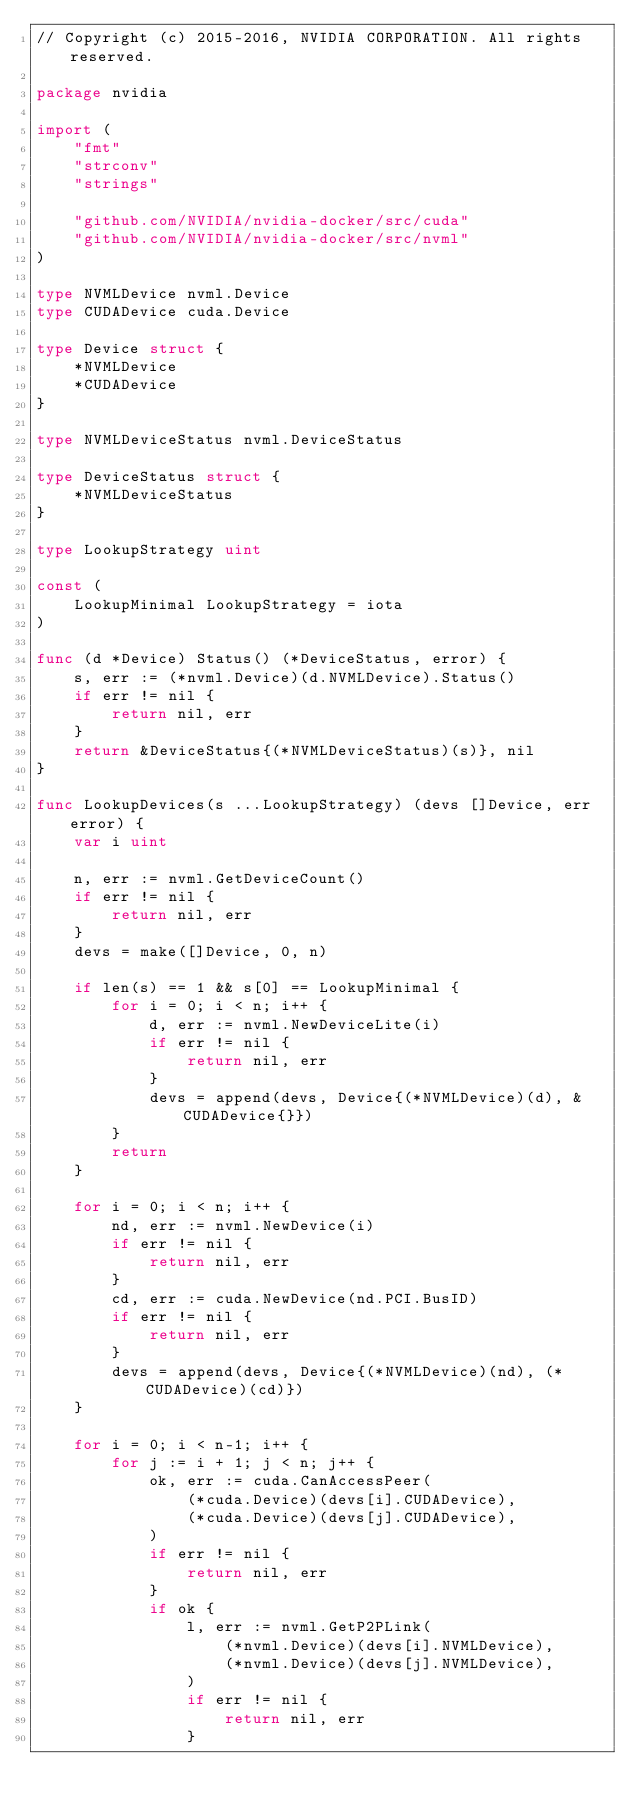Convert code to text. <code><loc_0><loc_0><loc_500><loc_500><_Go_>// Copyright (c) 2015-2016, NVIDIA CORPORATION. All rights reserved.

package nvidia

import (
	"fmt"
	"strconv"
	"strings"

	"github.com/NVIDIA/nvidia-docker/src/cuda"
	"github.com/NVIDIA/nvidia-docker/src/nvml"
)

type NVMLDevice nvml.Device
type CUDADevice cuda.Device

type Device struct {
	*NVMLDevice
	*CUDADevice
}

type NVMLDeviceStatus nvml.DeviceStatus

type DeviceStatus struct {
	*NVMLDeviceStatus
}

type LookupStrategy uint

const (
	LookupMinimal LookupStrategy = iota
)

func (d *Device) Status() (*DeviceStatus, error) {
	s, err := (*nvml.Device)(d.NVMLDevice).Status()
	if err != nil {
		return nil, err
	}
	return &DeviceStatus{(*NVMLDeviceStatus)(s)}, nil
}

func LookupDevices(s ...LookupStrategy) (devs []Device, err error) {
	var i uint

	n, err := nvml.GetDeviceCount()
	if err != nil {
		return nil, err
	}
	devs = make([]Device, 0, n)

	if len(s) == 1 && s[0] == LookupMinimal {
		for i = 0; i < n; i++ {
			d, err := nvml.NewDeviceLite(i)
			if err != nil {
				return nil, err
			}
			devs = append(devs, Device{(*NVMLDevice)(d), &CUDADevice{}})
		}
		return
	}

	for i = 0; i < n; i++ {
		nd, err := nvml.NewDevice(i)
		if err != nil {
			return nil, err
		}
		cd, err := cuda.NewDevice(nd.PCI.BusID)
		if err != nil {
			return nil, err
		}
		devs = append(devs, Device{(*NVMLDevice)(nd), (*CUDADevice)(cd)})
	}

	for i = 0; i < n-1; i++ {
		for j := i + 1; j < n; j++ {
			ok, err := cuda.CanAccessPeer(
				(*cuda.Device)(devs[i].CUDADevice),
				(*cuda.Device)(devs[j].CUDADevice),
			)
			if err != nil {
				return nil, err
			}
			if ok {
				l, err := nvml.GetP2PLink(
					(*nvml.Device)(devs[i].NVMLDevice),
					(*nvml.Device)(devs[j].NVMLDevice),
				)
				if err != nil {
					return nil, err
				}</code> 